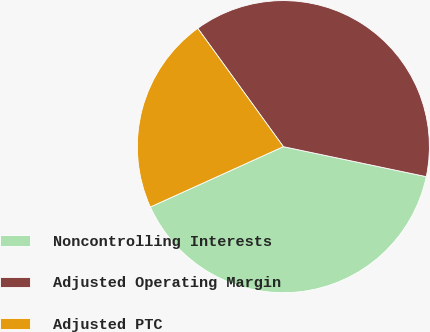<chart> <loc_0><loc_0><loc_500><loc_500><pie_chart><fcel>Noncontrolling Interests<fcel>Adjusted Operating Margin<fcel>Adjusted PTC<nl><fcel>39.93%<fcel>38.26%<fcel>21.81%<nl></chart> 